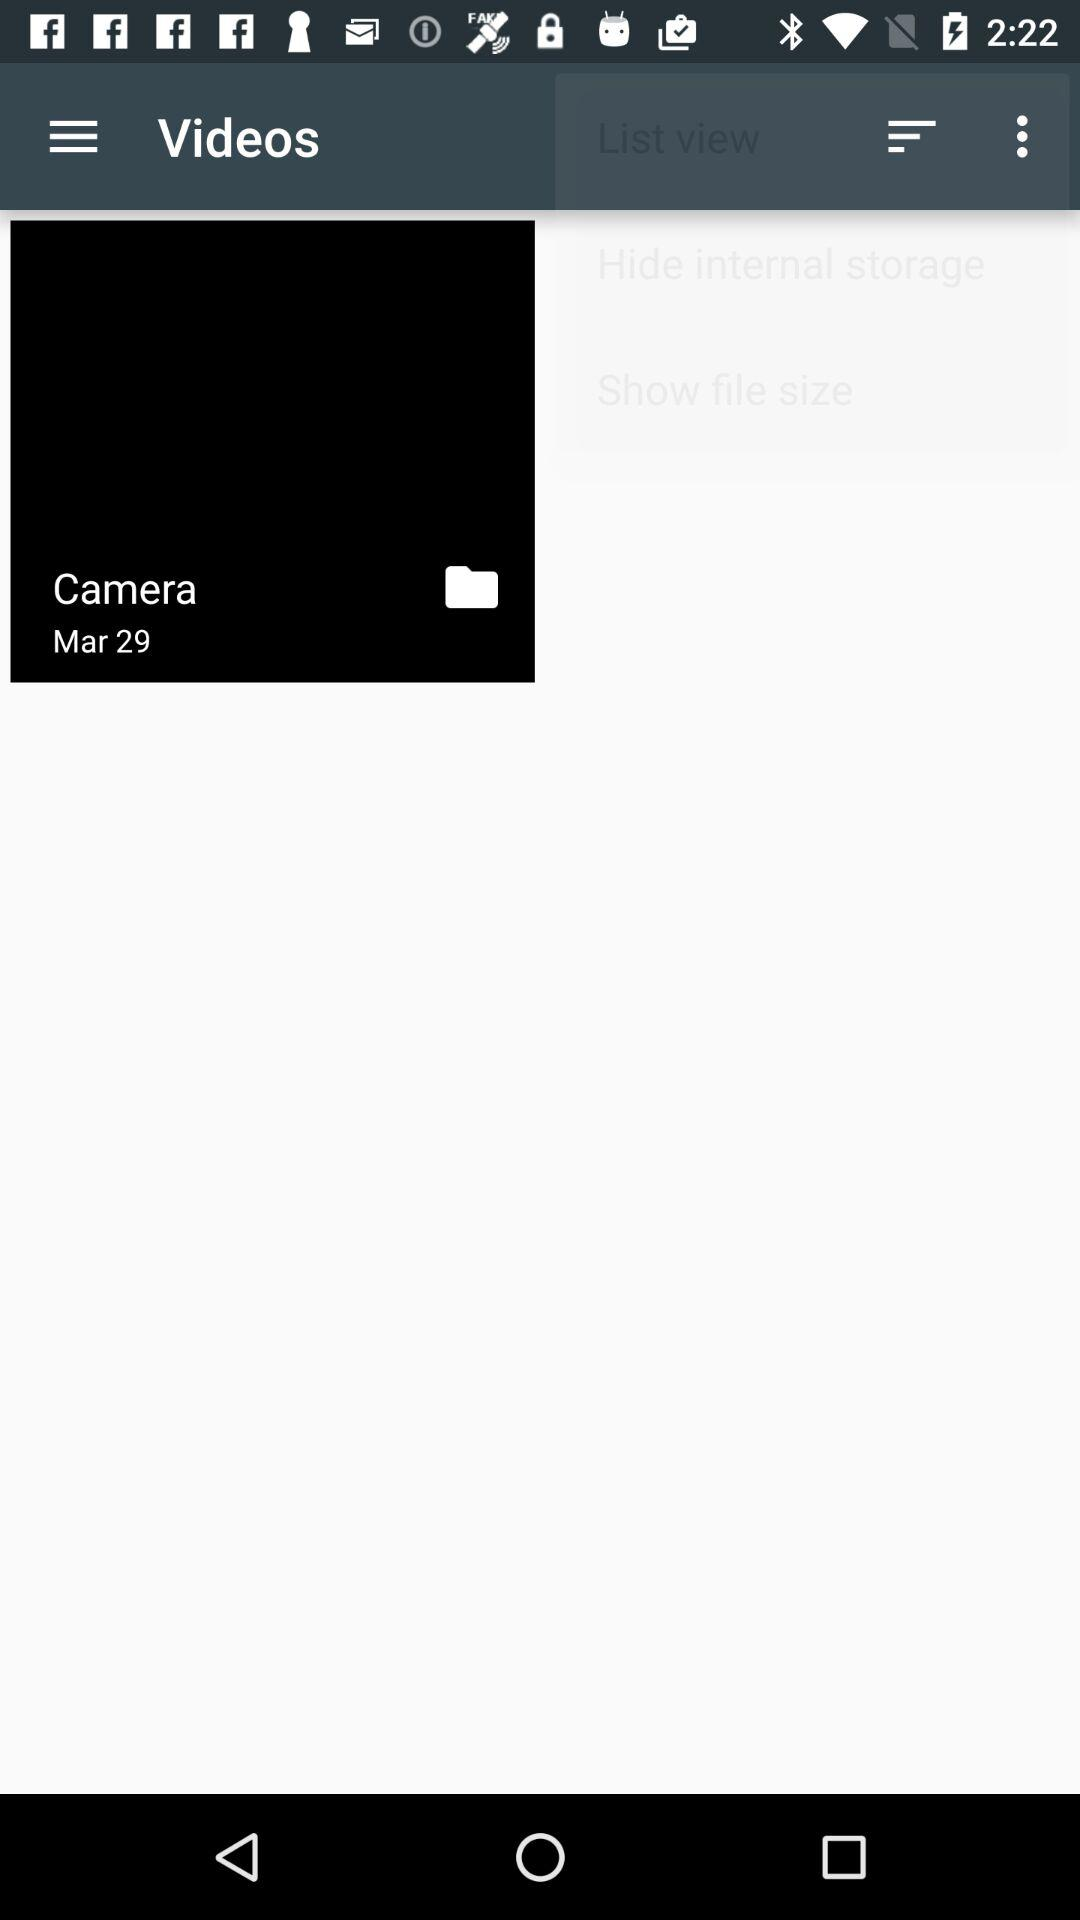Who posted the videos?
When the provided information is insufficient, respond with <no answer>. <no answer> 